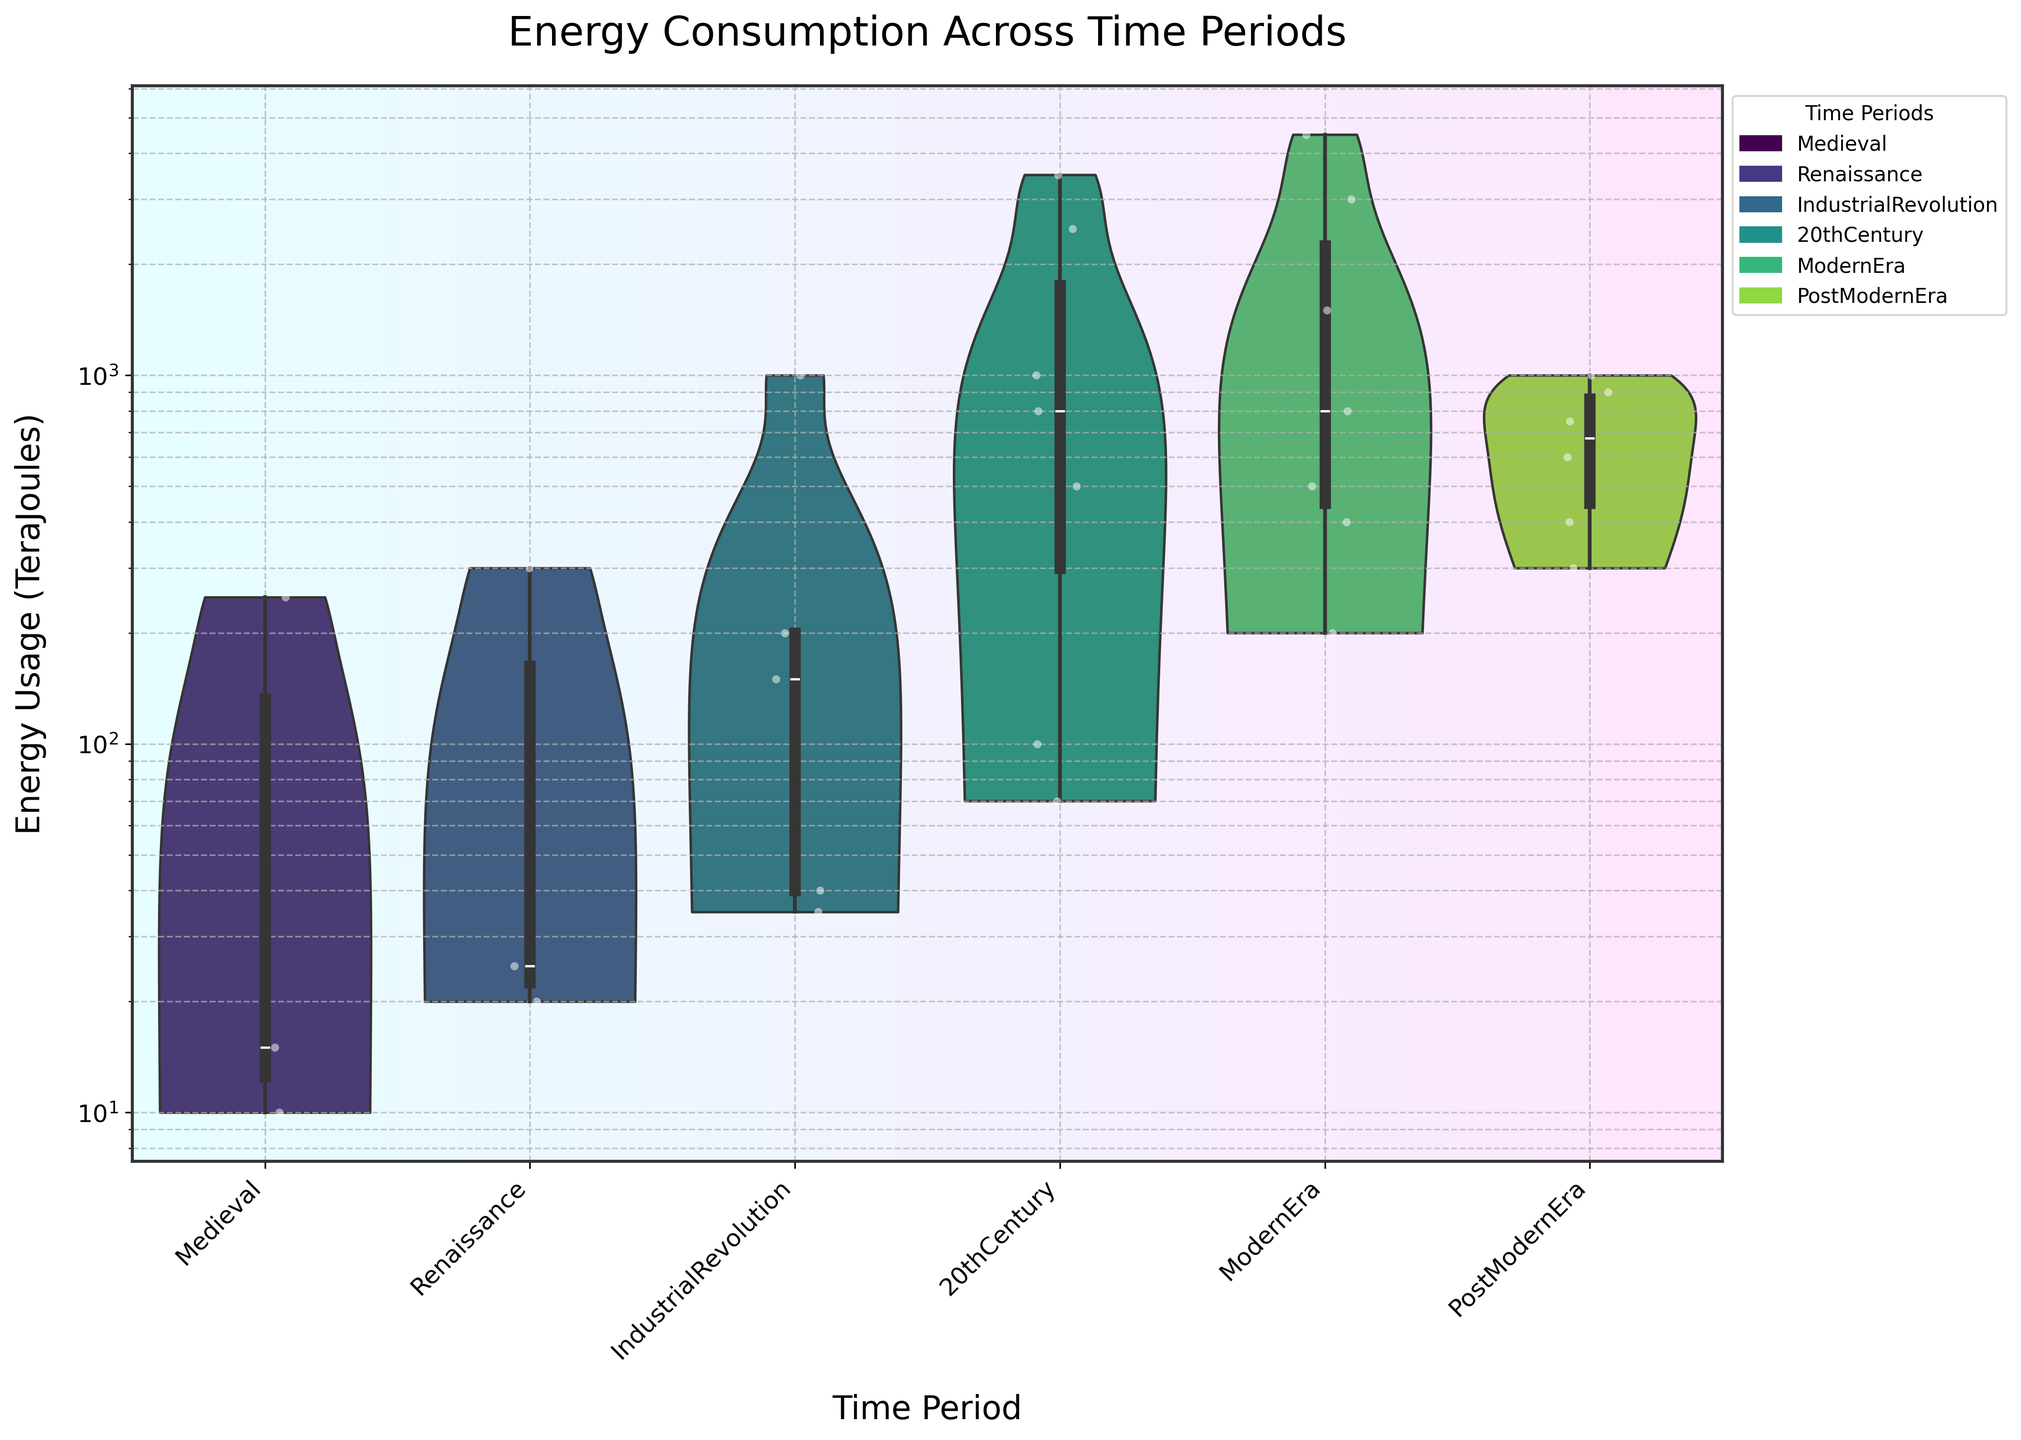What's the title of the chart? The title of the chart is prominently displayed at the top, and it reads 'Energy Consumption Across Time Periods'.
Answer: Energy Consumption Across Time Periods In which period is the usage of Nuclear energy observed? By looking at the figure, the usage of Nuclear energy falls under the 20th Century and the Modern Era.
Answer: 20th Century and Modern Era Which time period has the highest variety of energy sources? To determine this, count the number of different jittered points within each violin plot. The Modern Era and the PostModern Era have six different energy sources each.
Answer: Modern Era and PostModern Era What is the time period with the most skewed distribution of energy usage? The skewness can be evaluated by observing how the violin plots of energy usage are shaped. The 20th Century shows a highly unbalanced distribution as most energy usage is concentrated toward higher values like Oil and Coal.
Answer: 20th Century Which time period shows the highest median level of energy consumption? For violin plots, the wider part of the 'waist' of the plot indicates the median. The Industrial Revolution and 20th Century show higher median levels due to the prominent energy sources like Coal, Oil, and Gas.
Answer: 20th Century Compare the use of Solar energy in the Modern Era and PostModern Era. Which period used more Solar energy? The violin plots and the jittered points indicate that Solar energy usage is higher in the PostModern Era compared to the Modern Era.
Answer: PostModern Era How many energy sources are used in the Renaissance period according to the chart? Count the jittered points on the violin plot corresponding to the Renaissance period. There are three distinct points, indicating three different energy sources.
Answer: Three Which period shows a notable increase in varied energy sources compared to the previous one? Observe the transition between periods by comparing the diversity of jittered points. The Modern Era shows a large increase in varied energy sources compared to the 20th Century.
Answer: Modern Era What type of plot is used to visualize the energy consumption data over different time periods? The figure uses a violin plot combined with jittered points to visualize the energy consumption data across different historic periods.
Answer: Violin plot with jittered points 